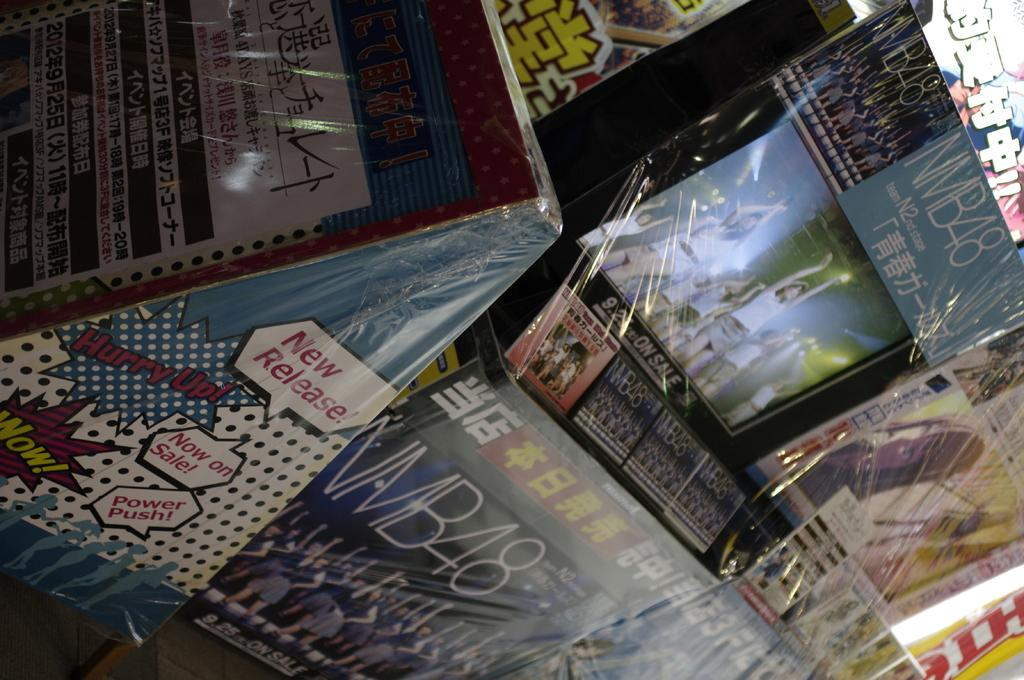<image>
Create a compact narrative representing the image presented. Display of different items in a store with one that says "NMB48". 